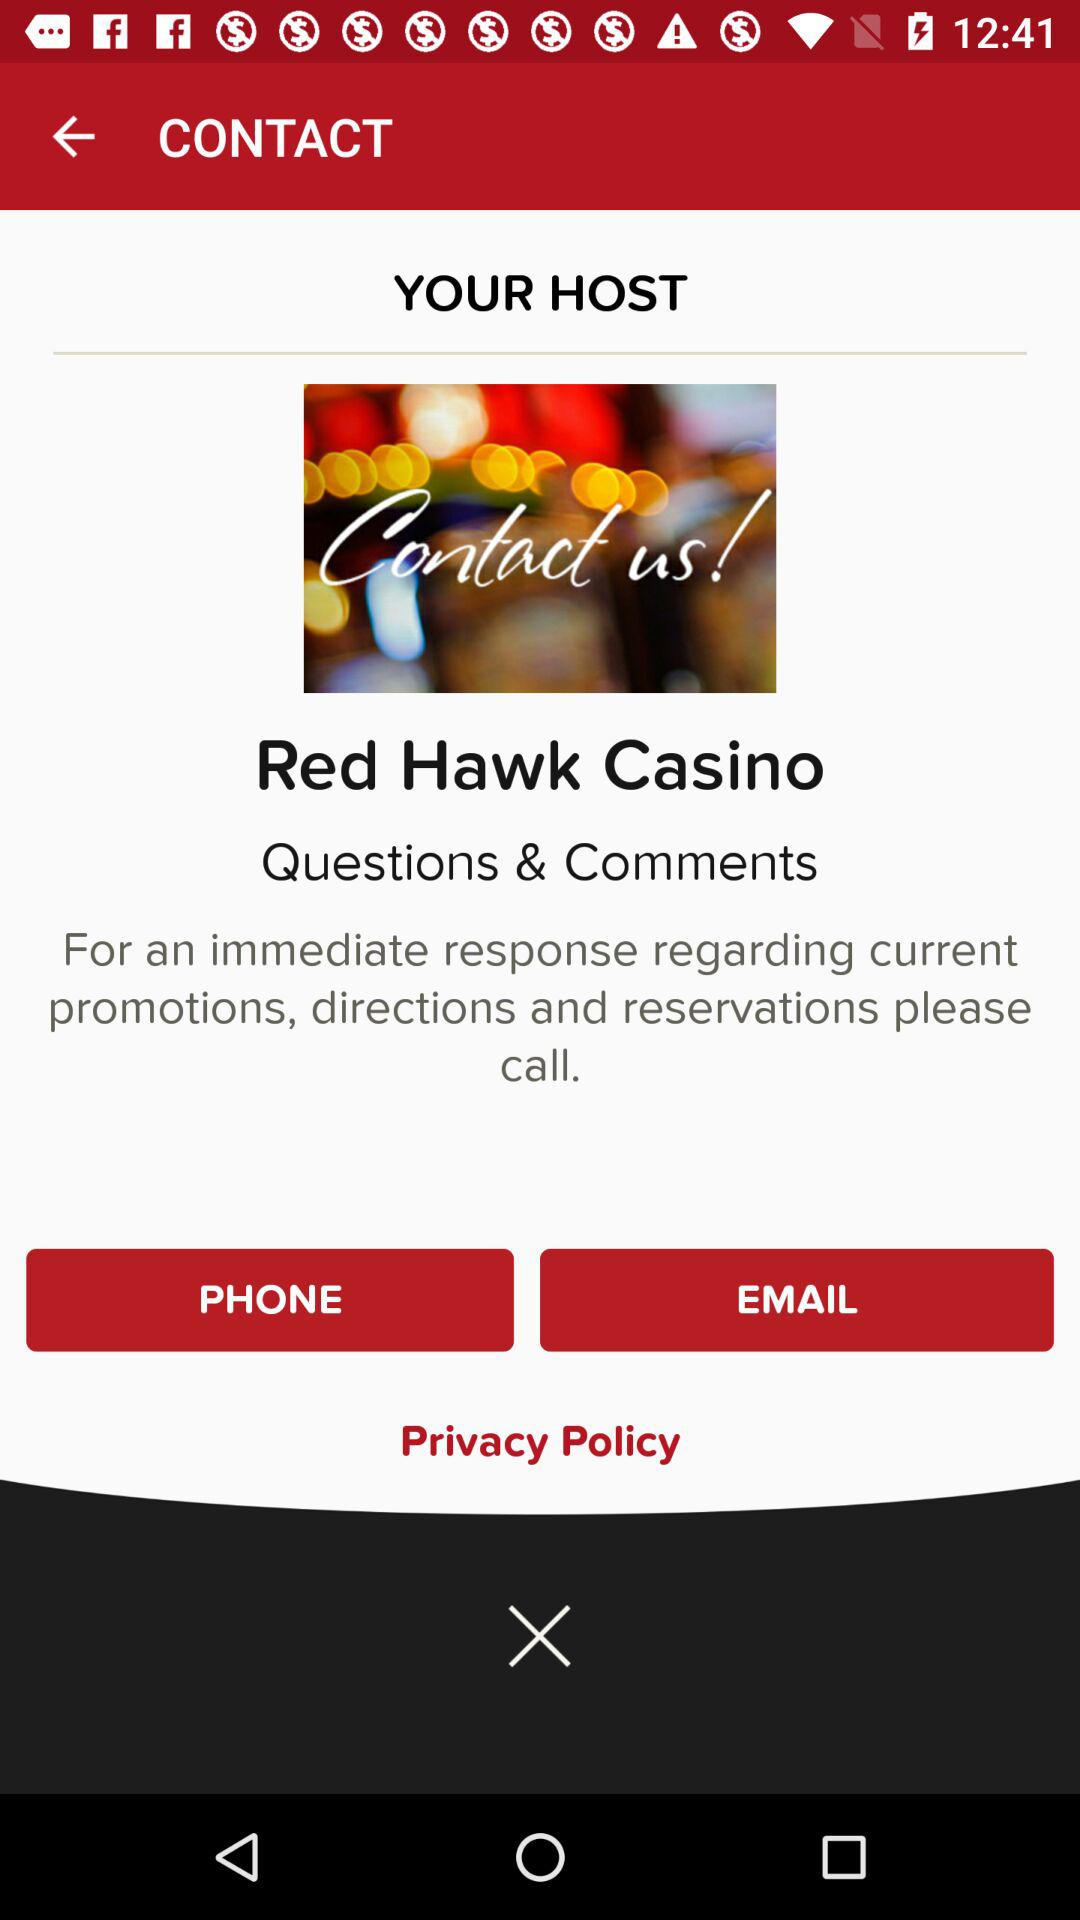What are the options given for the response regarding current promotions, directions and reservations? The given options are "PHONE" and "EMAIL". 